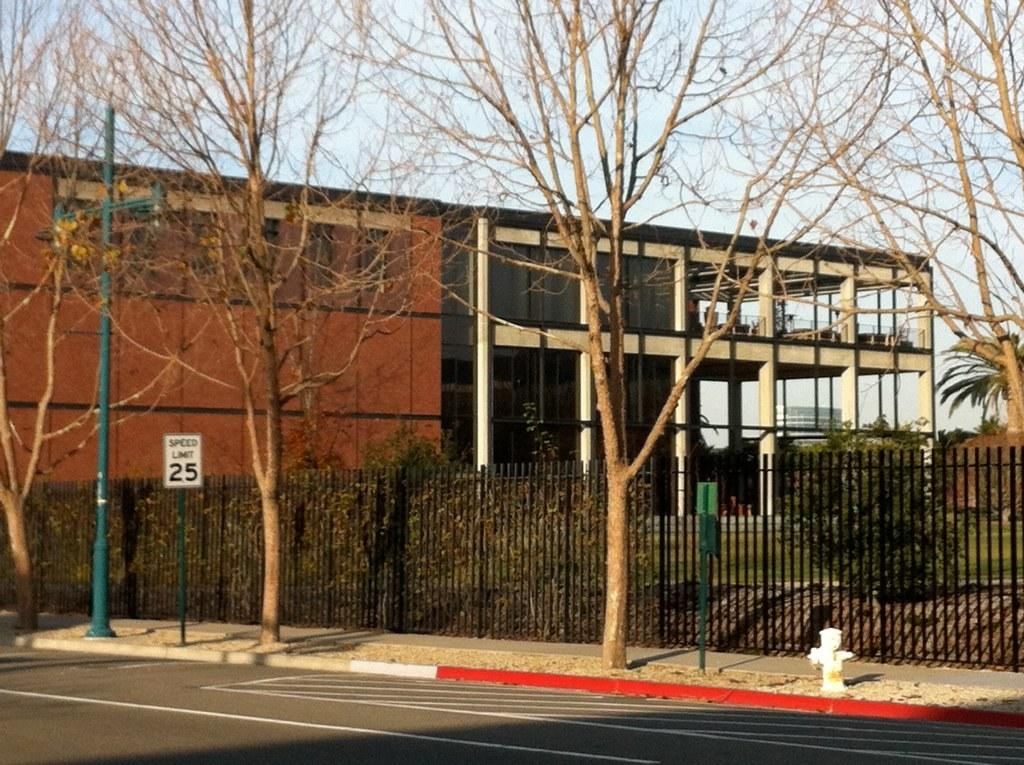What is located in the center of the image? There are trees, plants, grass, poles, a sign board, a fence, a road, and a water pole in the center of the image. Can you describe the background of the image? The background of the image includes a sky, a wall, clouds, and buildings. Are there any architectural features visible in the background? Yes, there are pillars visible in the background. What type of crow is perched on the tail of the person in the image? There is no crow or person present in the image. What does the mouth of the tree look like in the image? There are no mouths present in the image, as trees do not have mouths. 